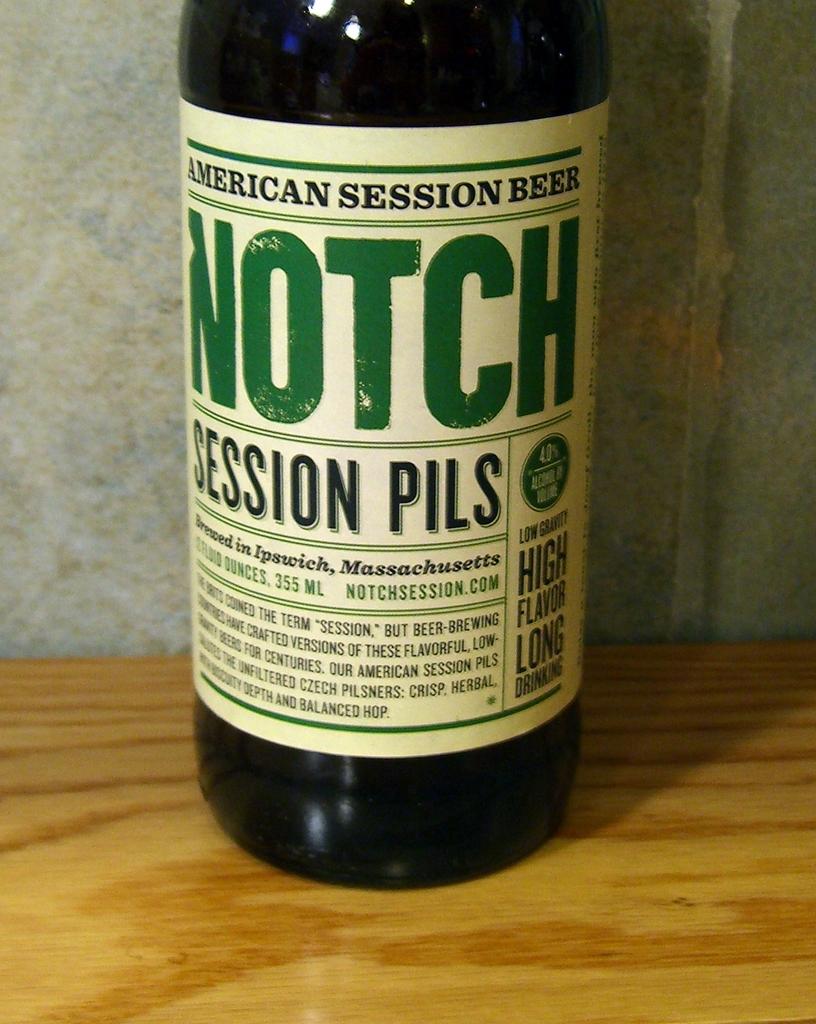What state is this beer from?
Keep it short and to the point. Massachusetts. Is notch beer a pilser?
Keep it short and to the point. Yes. 